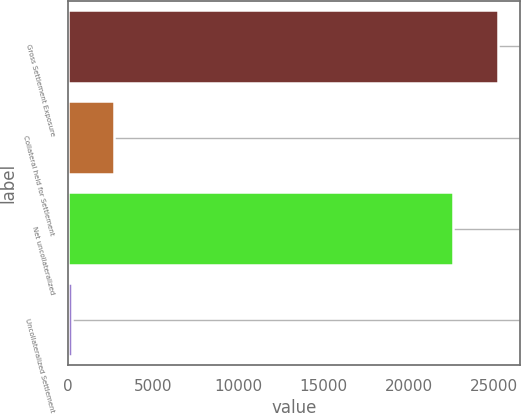Convert chart. <chart><loc_0><loc_0><loc_500><loc_500><bar_chart><fcel>Gross Settlement Exposure<fcel>Collateral held for Settlement<fcel>Net uncollateralized<fcel>Uncollateralized Settlement<nl><fcel>25279<fcel>2712.4<fcel>22591<fcel>205<nl></chart> 